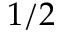Convert formula to latex. <formula><loc_0><loc_0><loc_500><loc_500>1 / 2</formula> 